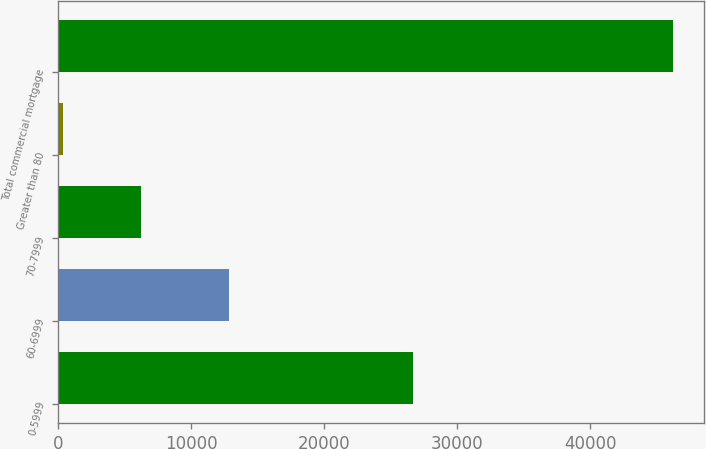<chart> <loc_0><loc_0><loc_500><loc_500><bar_chart><fcel>0-5999<fcel>60-6999<fcel>70-7999<fcel>Greater than 80<fcel>Total commercial mortgage<nl><fcel>26700<fcel>12820<fcel>6265<fcel>402<fcel>46187<nl></chart> 